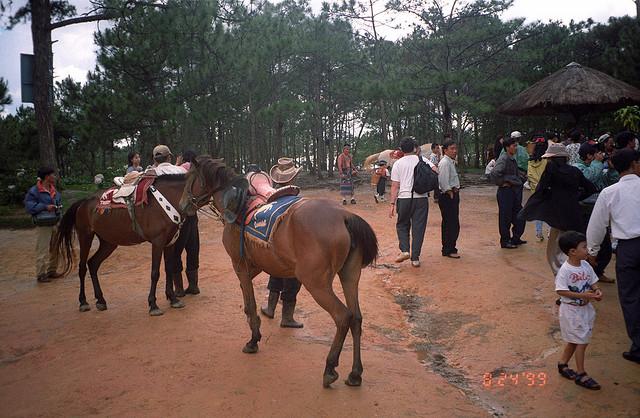Are all the animals in this picture the same color?
Short answer required. Yes. How many horses are there?
Concise answer only. 2. What year was this photo taken?
Answer briefly. 1999. Which type of shoes does the small boy have?
Concise answer only. Sandals. 